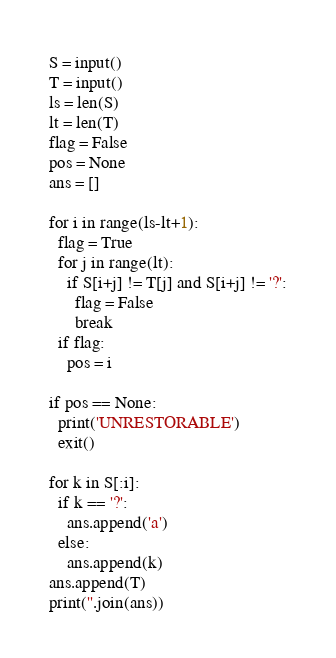<code> <loc_0><loc_0><loc_500><loc_500><_Python_>S = input()
T = input()
ls = len(S)
lt = len(T)
flag = False
pos = None
ans = []

for i in range(ls-lt+1):
  flag = True
  for j in range(lt):
    if S[i+j] != T[j] and S[i+j] != '?':
      flag = False
      break
  if flag:
    pos = i

if pos == None:
  print('UNRESTORABLE')
  exit()

for k in S[:i]:
  if k == '?':
    ans.append('a')
  else:
    ans.append(k)
ans.append(T)
print(''.join(ans))</code> 